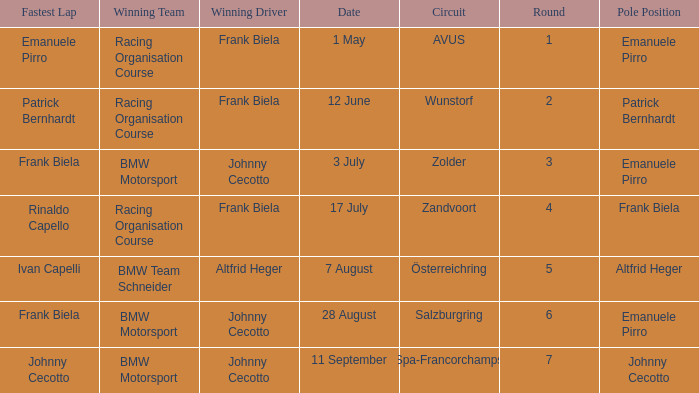What round was circuit Avus? 1.0. 